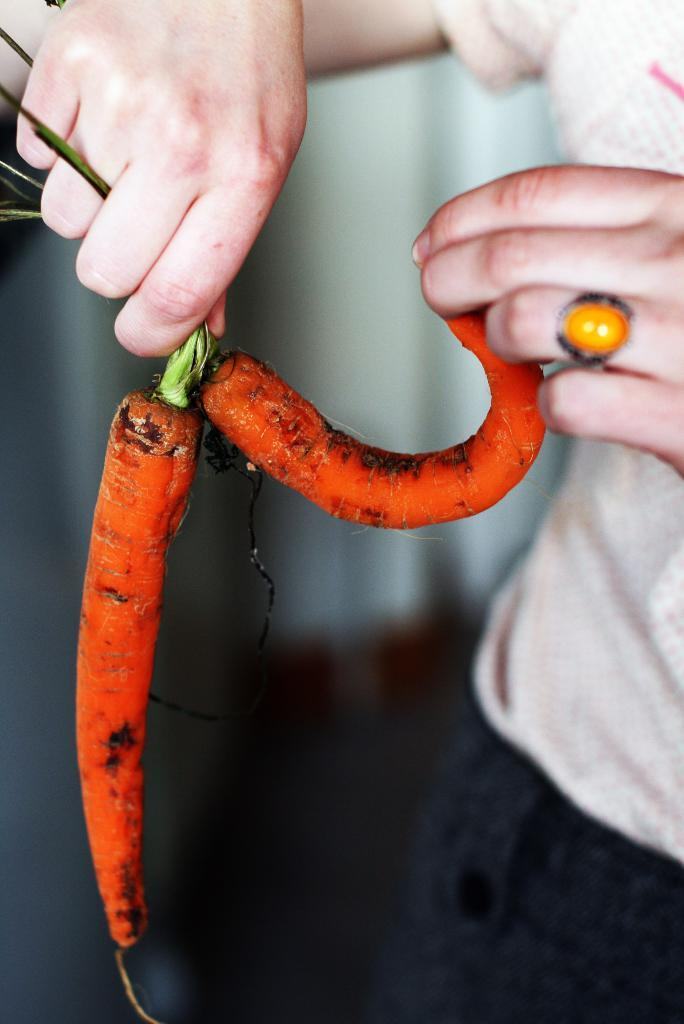What is the main subject of the image? There is a person in the image. What is the person holding in the image? The person is holding carrots. Can you describe the background of the image? The background of the image is blurry. What type of rock can be seen being offered by the person in the image? There is no rock present in the image; the person is holding carrots. What is the person offering to the quince in the image? There is no quince present in the image, and the person is not offering anything to a quince. 